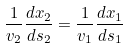<formula> <loc_0><loc_0><loc_500><loc_500>\frac { 1 } { v _ { 2 } } \frac { d x _ { 2 } } { d s _ { 2 } } = \frac { 1 } { v _ { 1 } } \frac { d x _ { 1 } } { d s _ { 1 } }</formula> 